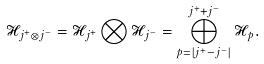<formula> <loc_0><loc_0><loc_500><loc_500>\mathcal { H } _ { j ^ { + } \otimes j ^ { - } } = \mathcal { H } _ { j ^ { + } } \bigotimes \mathcal { H } _ { j ^ { - } } = \bigoplus _ { p = | j ^ { + } - j ^ { - } | } ^ { j ^ { + } + j ^ { - } } \mathcal { H } _ { p } .</formula> 